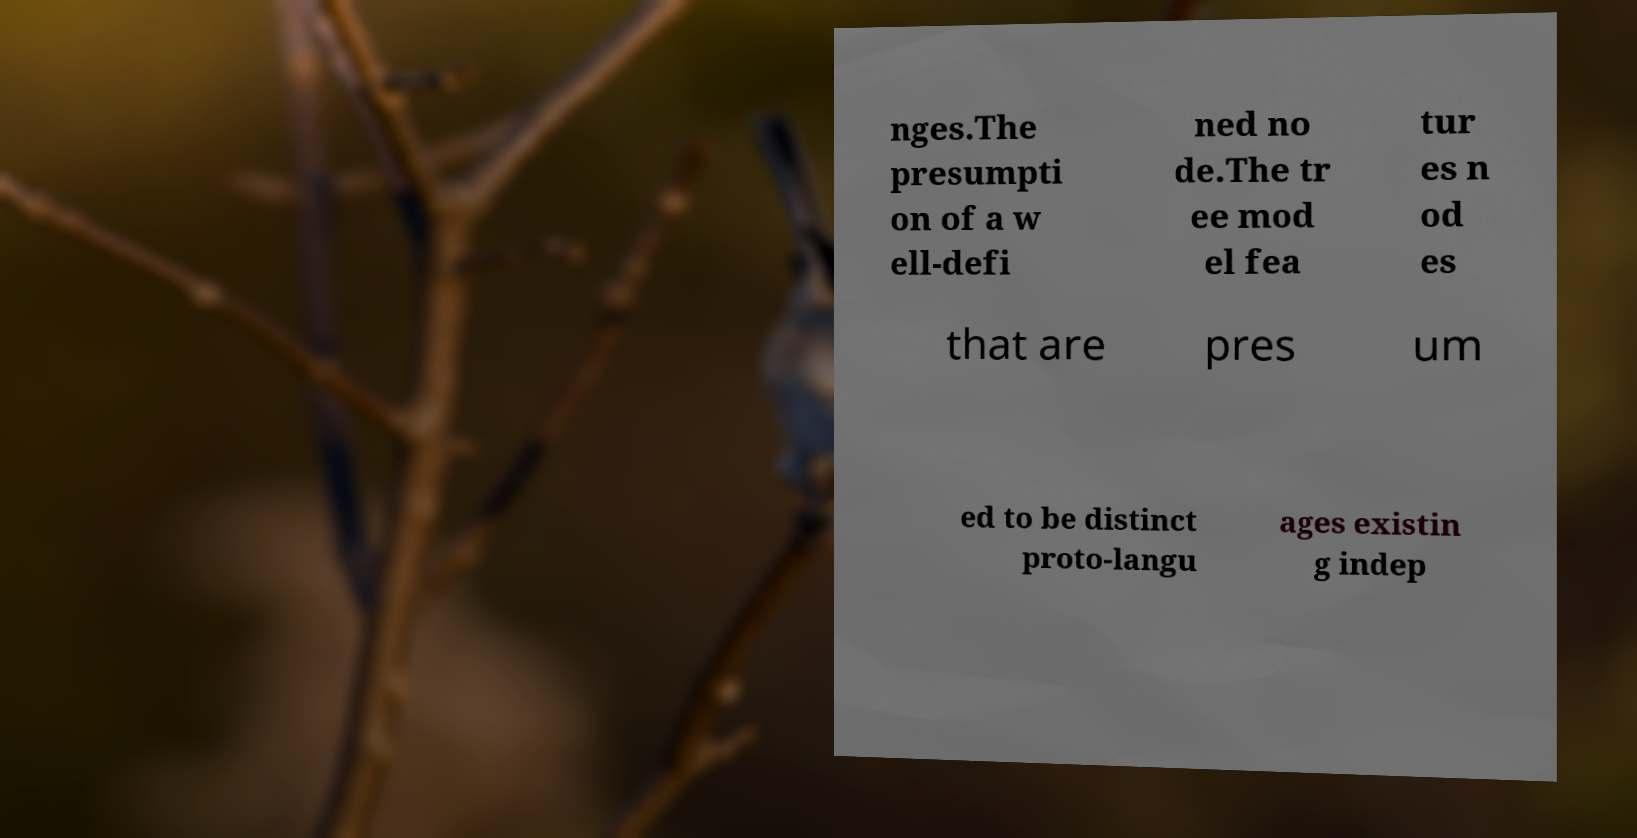For documentation purposes, I need the text within this image transcribed. Could you provide that? nges.The presumpti on of a w ell-defi ned no de.The tr ee mod el fea tur es n od es that are pres um ed to be distinct proto-langu ages existin g indep 